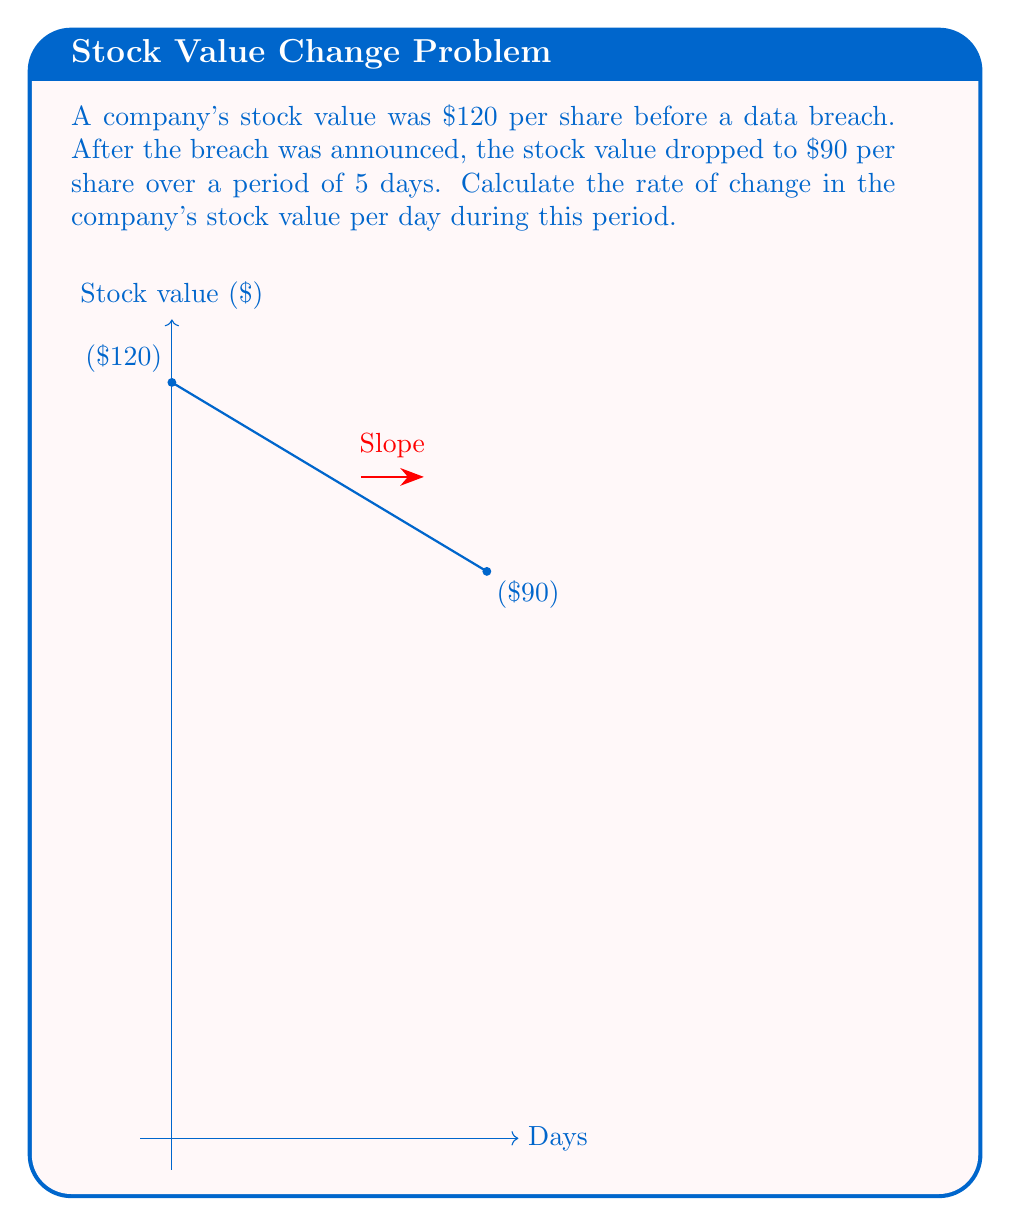Can you answer this question? To calculate the rate of change in the company's stock value per day, we need to use the slope formula:

$$\text{Rate of change} = \frac{\text{Change in y}}{\text{Change in x}} = \frac{\text{Change in stock value}}{\text{Change in time}}$$

Let's identify our values:
- Initial stock value: $120
- Final stock value: $90
- Time period: 5 days

Now, let's plug these values into our formula:

$$\text{Rate of change} = \frac{90 - 120}{5 - 0} = \frac{-30}{5}$$

Simplifying this fraction:

$$\text{Rate of change} = -6$$

The negative sign indicates a decrease in value.

Therefore, the rate of change in the company's stock value is -$6 per day.
Answer: -$6 per day 